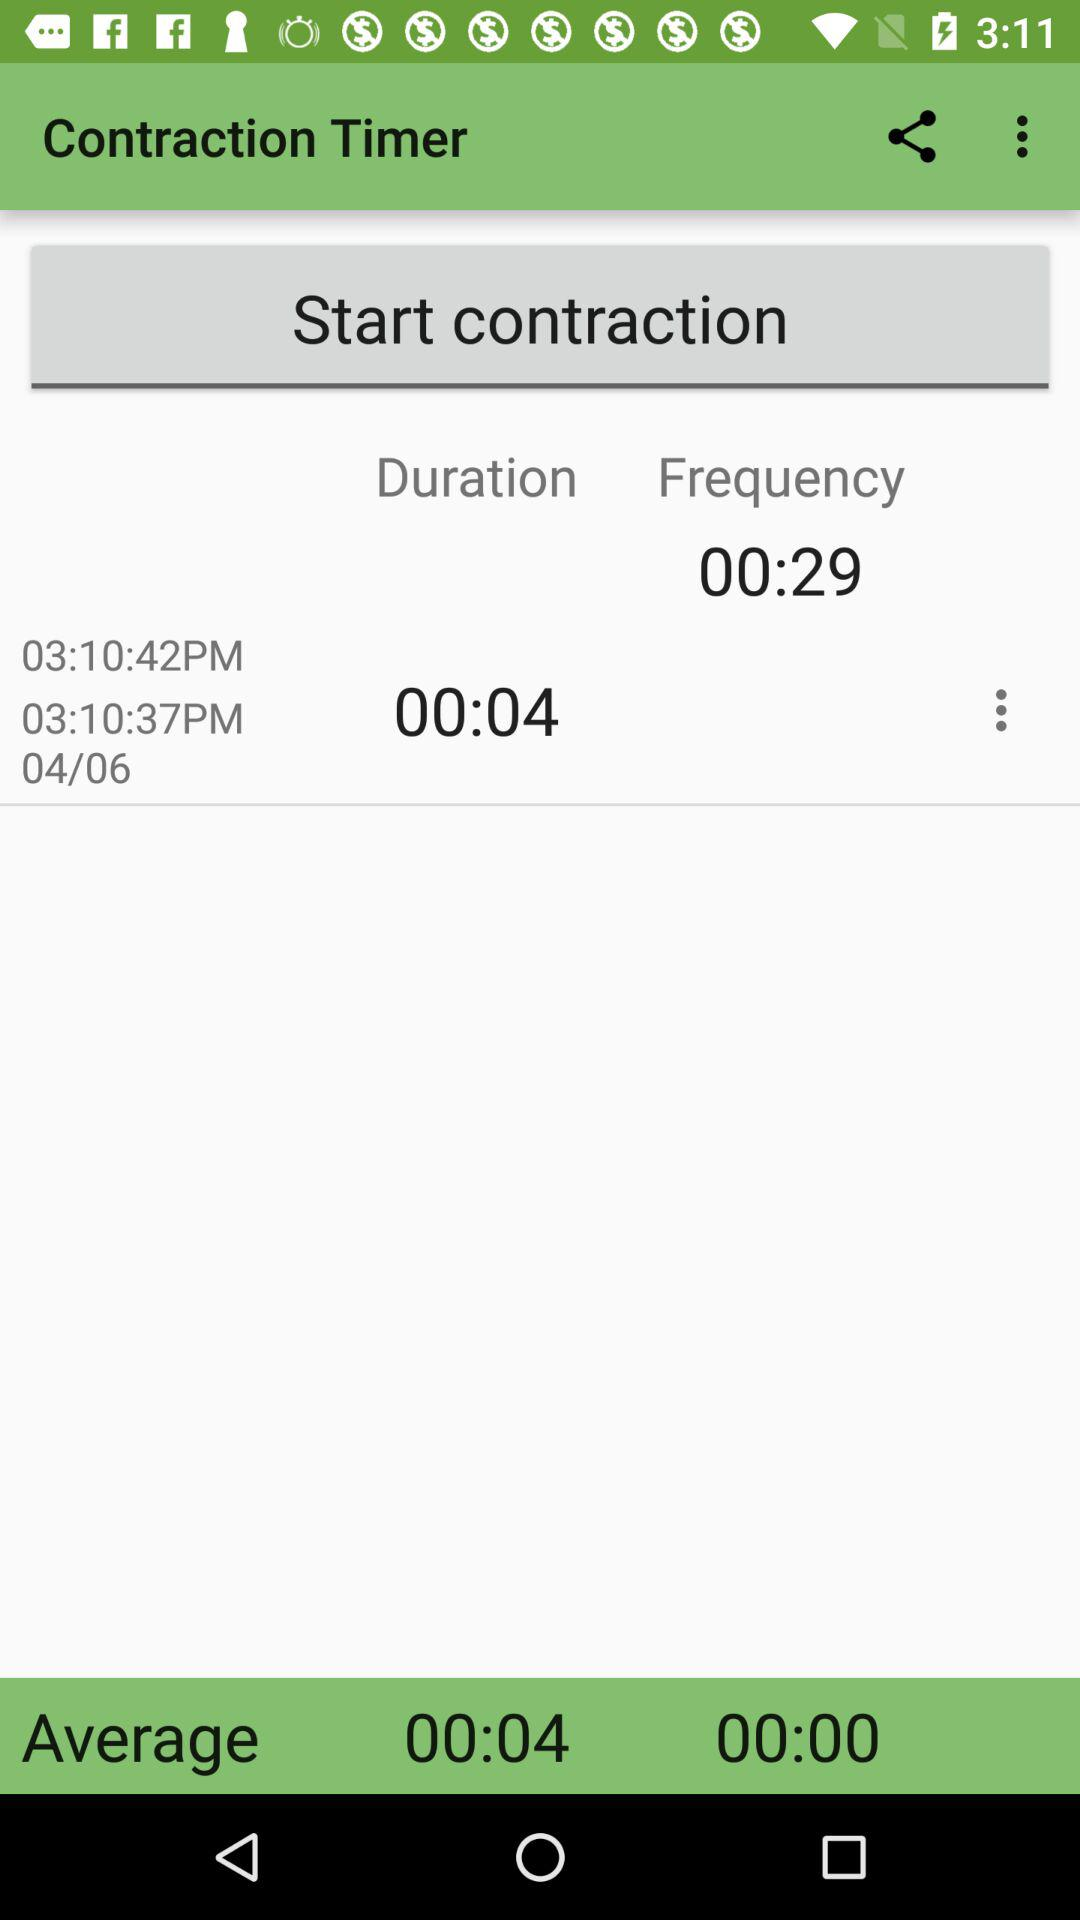What is the duration set? The duration set is 00:04. 